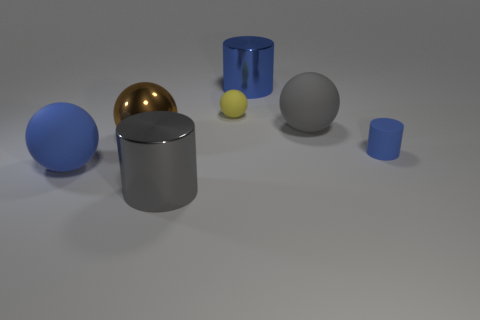Add 2 gray objects. How many objects exist? 9 Subtract all cylinders. How many objects are left? 4 Add 7 small things. How many small things are left? 9 Add 7 small brown blocks. How many small brown blocks exist? 7 Subtract 0 green balls. How many objects are left? 7 Subtract all blue matte things. Subtract all blue cylinders. How many objects are left? 3 